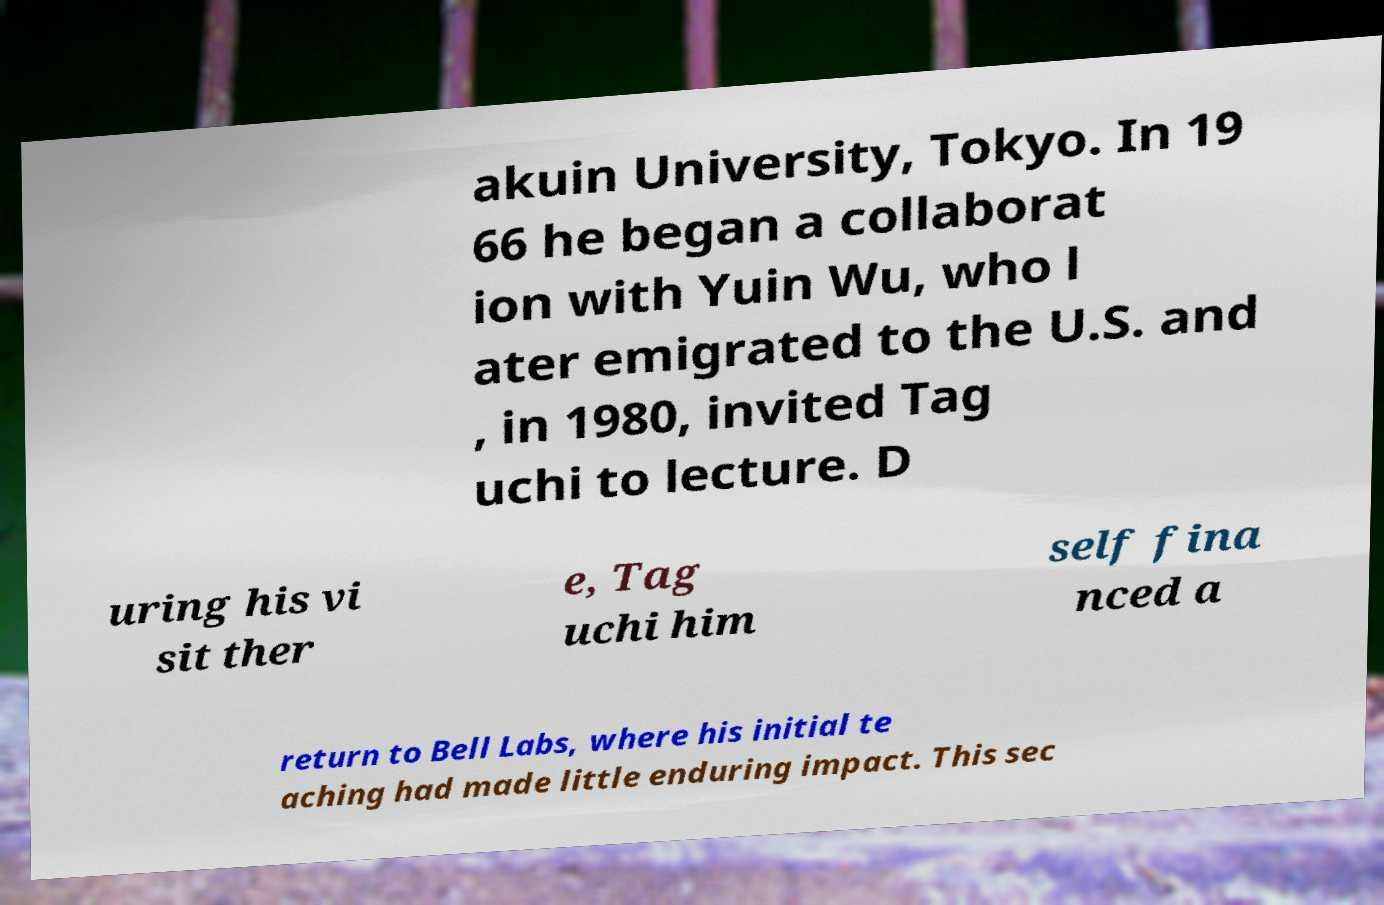Please identify and transcribe the text found in this image. akuin University, Tokyo. In 19 66 he began a collaborat ion with Yuin Wu, who l ater emigrated to the U.S. and , in 1980, invited Tag uchi to lecture. D uring his vi sit ther e, Tag uchi him self fina nced a return to Bell Labs, where his initial te aching had made little enduring impact. This sec 